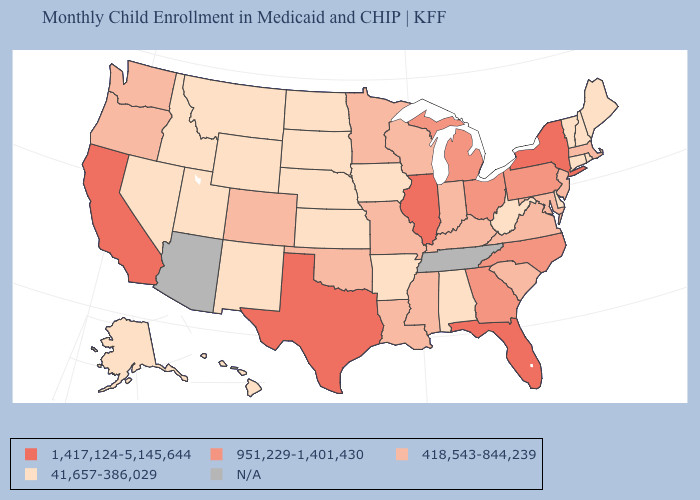What is the lowest value in states that border Utah?
Answer briefly. 41,657-386,029. Name the states that have a value in the range 41,657-386,029?
Answer briefly. Alabama, Alaska, Arkansas, Connecticut, Delaware, Hawaii, Idaho, Iowa, Kansas, Maine, Montana, Nebraska, Nevada, New Hampshire, New Mexico, North Dakota, Rhode Island, South Dakota, Utah, Vermont, West Virginia, Wyoming. What is the value of Iowa?
Write a very short answer. 41,657-386,029. Name the states that have a value in the range 41,657-386,029?
Give a very brief answer. Alabama, Alaska, Arkansas, Connecticut, Delaware, Hawaii, Idaho, Iowa, Kansas, Maine, Montana, Nebraska, Nevada, New Hampshire, New Mexico, North Dakota, Rhode Island, South Dakota, Utah, Vermont, West Virginia, Wyoming. What is the highest value in the USA?
Concise answer only. 1,417,124-5,145,644. Name the states that have a value in the range 1,417,124-5,145,644?
Quick response, please. California, Florida, Illinois, New York, Texas. What is the value of Colorado?
Be succinct. 418,543-844,239. Does the first symbol in the legend represent the smallest category?
Quick response, please. No. Name the states that have a value in the range 1,417,124-5,145,644?
Keep it brief. California, Florida, Illinois, New York, Texas. Does Florida have the lowest value in the South?
Short answer required. No. Which states have the lowest value in the West?
Concise answer only. Alaska, Hawaii, Idaho, Montana, Nevada, New Mexico, Utah, Wyoming. Name the states that have a value in the range 41,657-386,029?
Quick response, please. Alabama, Alaska, Arkansas, Connecticut, Delaware, Hawaii, Idaho, Iowa, Kansas, Maine, Montana, Nebraska, Nevada, New Hampshire, New Mexico, North Dakota, Rhode Island, South Dakota, Utah, Vermont, West Virginia, Wyoming. What is the highest value in the West ?
Keep it brief. 1,417,124-5,145,644. Which states have the highest value in the USA?
Give a very brief answer. California, Florida, Illinois, New York, Texas. 